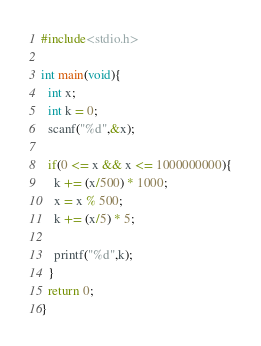Convert code to text. <code><loc_0><loc_0><loc_500><loc_500><_C_>#include<stdio.h>
 
int main(void){
  int x;
  int k = 0;
  scanf("%d",&x);
  
  if(0 <= x && x <= 1000000000){
 	k += (x/500) * 1000;
  	x = x % 500;
  	k += (x/5) * 5;
  
	printf("%d",k);
  }
  return 0;
}</code> 